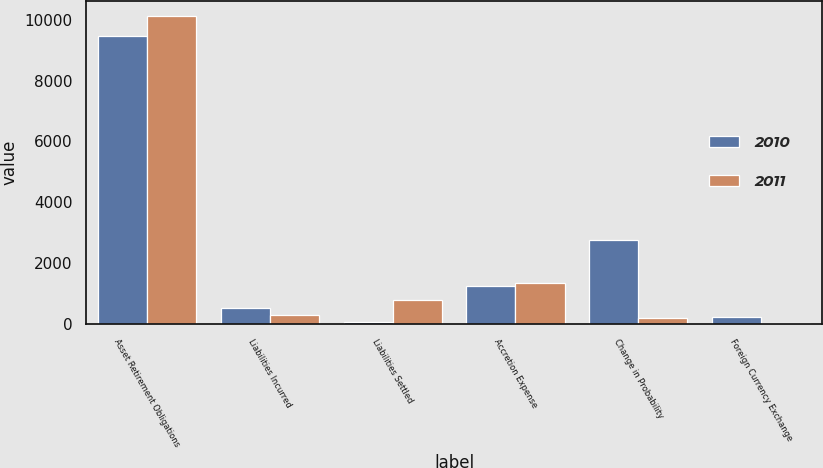<chart> <loc_0><loc_0><loc_500><loc_500><stacked_bar_chart><ecel><fcel>Asset Retirement Obligations<fcel>Liabilities Incurred<fcel>Liabilities Settled<fcel>Accretion Expense<fcel>Change in Probability<fcel>Foreign Currency Exchange<nl><fcel>2010<fcel>9465<fcel>531<fcel>70<fcel>1254<fcel>2745<fcel>239<nl><fcel>2011<fcel>10116<fcel>300<fcel>774<fcel>1327<fcel>176<fcel>26<nl></chart> 